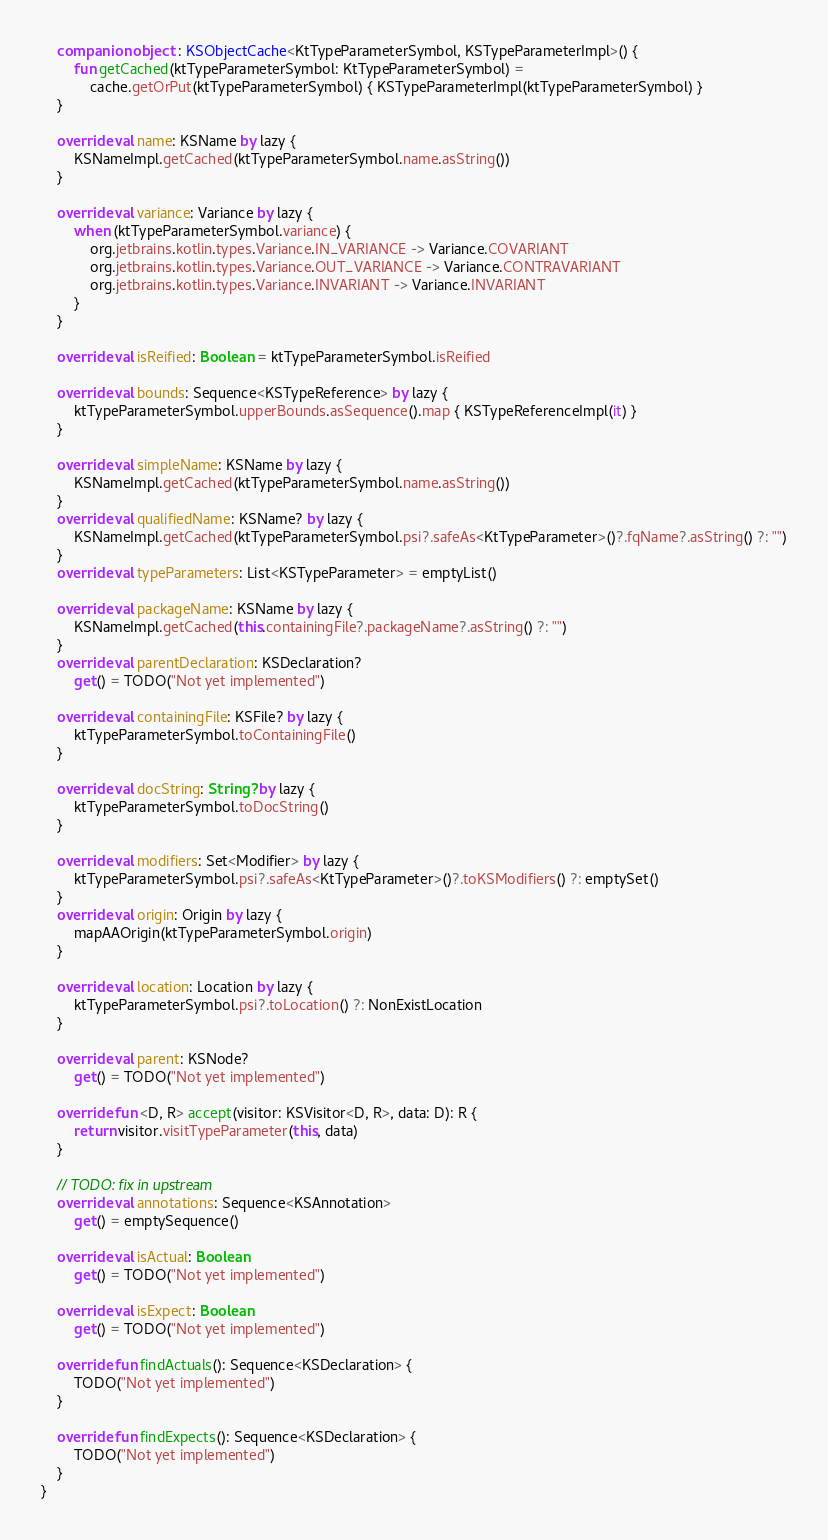Convert code to text. <code><loc_0><loc_0><loc_500><loc_500><_Kotlin_>    companion object : KSObjectCache<KtTypeParameterSymbol, KSTypeParameterImpl>() {
        fun getCached(ktTypeParameterSymbol: KtTypeParameterSymbol) =
            cache.getOrPut(ktTypeParameterSymbol) { KSTypeParameterImpl(ktTypeParameterSymbol) }
    }

    override val name: KSName by lazy {
        KSNameImpl.getCached(ktTypeParameterSymbol.name.asString())
    }

    override val variance: Variance by lazy {
        when (ktTypeParameterSymbol.variance) {
            org.jetbrains.kotlin.types.Variance.IN_VARIANCE -> Variance.COVARIANT
            org.jetbrains.kotlin.types.Variance.OUT_VARIANCE -> Variance.CONTRAVARIANT
            org.jetbrains.kotlin.types.Variance.INVARIANT -> Variance.INVARIANT
        }
    }

    override val isReified: Boolean = ktTypeParameterSymbol.isReified

    override val bounds: Sequence<KSTypeReference> by lazy {
        ktTypeParameterSymbol.upperBounds.asSequence().map { KSTypeReferenceImpl(it) }
    }

    override val simpleName: KSName by lazy {
        KSNameImpl.getCached(ktTypeParameterSymbol.name.asString())
    }
    override val qualifiedName: KSName? by lazy {
        KSNameImpl.getCached(ktTypeParameterSymbol.psi?.safeAs<KtTypeParameter>()?.fqName?.asString() ?: "")
    }
    override val typeParameters: List<KSTypeParameter> = emptyList()

    override val packageName: KSName by lazy {
        KSNameImpl.getCached(this.containingFile?.packageName?.asString() ?: "")
    }
    override val parentDeclaration: KSDeclaration?
        get() = TODO("Not yet implemented")

    override val containingFile: KSFile? by lazy {
        ktTypeParameterSymbol.toContainingFile()
    }

    override val docString: String? by lazy {
        ktTypeParameterSymbol.toDocString()
    }

    override val modifiers: Set<Modifier> by lazy {
        ktTypeParameterSymbol.psi?.safeAs<KtTypeParameter>()?.toKSModifiers() ?: emptySet()
    }
    override val origin: Origin by lazy {
        mapAAOrigin(ktTypeParameterSymbol.origin)
    }

    override val location: Location by lazy {
        ktTypeParameterSymbol.psi?.toLocation() ?: NonExistLocation
    }

    override val parent: KSNode?
        get() = TODO("Not yet implemented")

    override fun <D, R> accept(visitor: KSVisitor<D, R>, data: D): R {
        return visitor.visitTypeParameter(this, data)
    }

    // TODO: fix in upstream
    override val annotations: Sequence<KSAnnotation>
        get() = emptySequence()

    override val isActual: Boolean
        get() = TODO("Not yet implemented")

    override val isExpect: Boolean
        get() = TODO("Not yet implemented")

    override fun findActuals(): Sequence<KSDeclaration> {
        TODO("Not yet implemented")
    }

    override fun findExpects(): Sequence<KSDeclaration> {
        TODO("Not yet implemented")
    }
}
</code> 